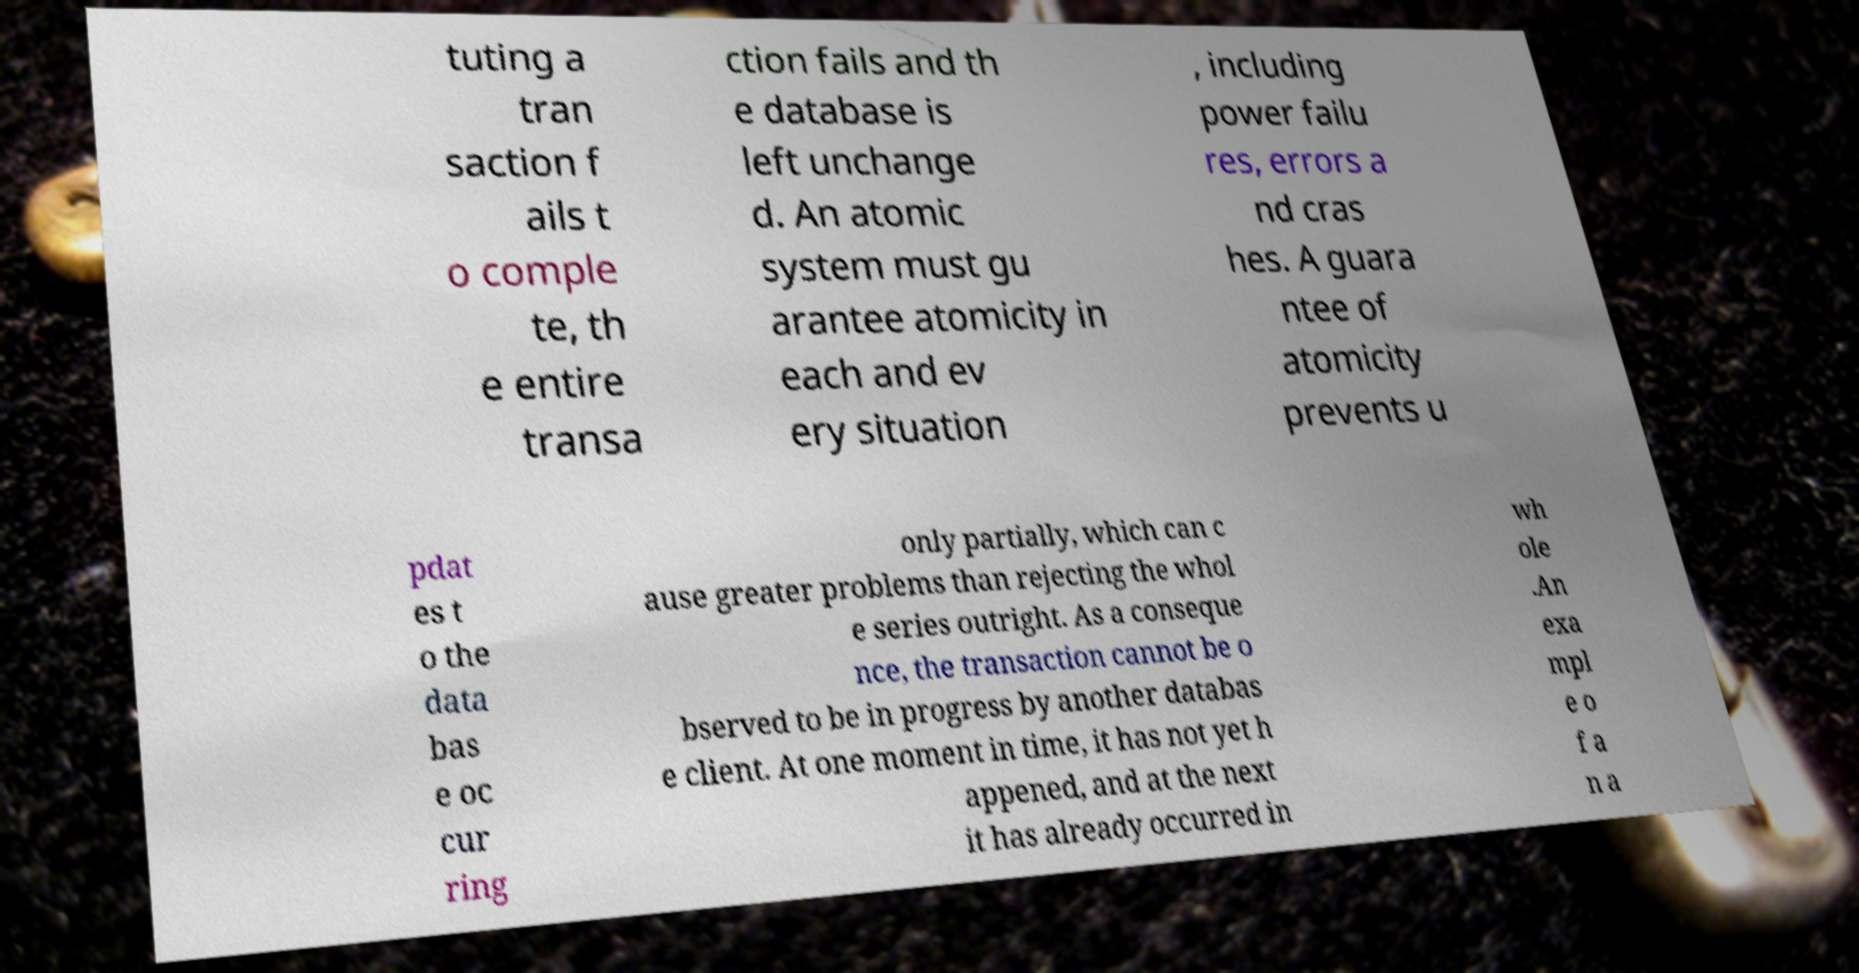Could you assist in decoding the text presented in this image and type it out clearly? tuting a tran saction f ails t o comple te, th e entire transa ction fails and th e database is left unchange d. An atomic system must gu arantee atomicity in each and ev ery situation , including power failu res, errors a nd cras hes. A guara ntee of atomicity prevents u pdat es t o the data bas e oc cur ring only partially, which can c ause greater problems than rejecting the whol e series outright. As a conseque nce, the transaction cannot be o bserved to be in progress by another databas e client. At one moment in time, it has not yet h appened, and at the next it has already occurred in wh ole .An exa mpl e o f a n a 